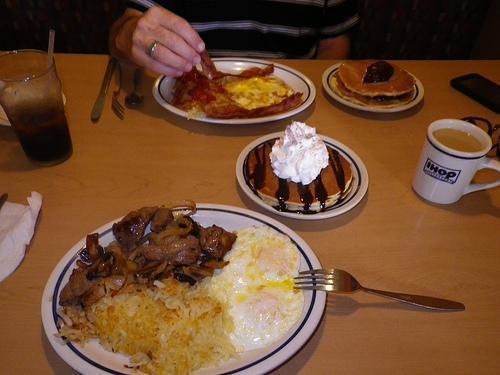How many pancakes are in the photo?
Give a very brief answer. 4. How many forks are in the photo?
Give a very brief answer. 2. 